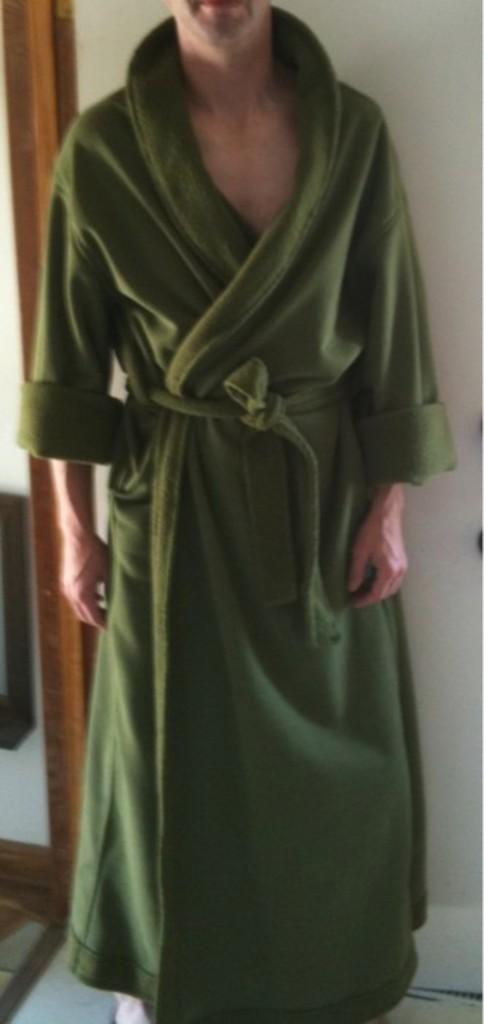What type of clothing is the person wearing in the image? The person is wearing a green bath coat. What color is the cloud in the image? There is no cloud present in the image; it only shows a person wearing a green bath coat. What type of twig can be seen in the person's eye in the image? There is no twig or any foreign object in the person's eye in the image. 